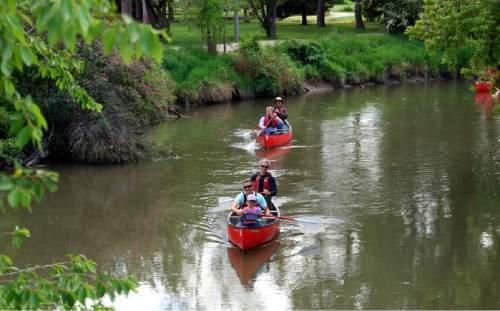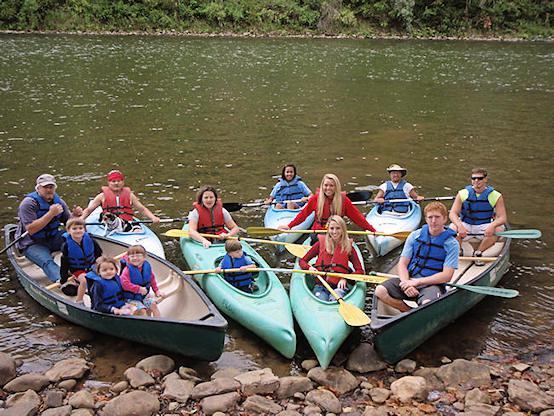The first image is the image on the left, the second image is the image on the right. Given the left and right images, does the statement "The left image contains at least one canoe with multiple people in it heading forward on the water." hold true? Answer yes or no. Yes. The first image is the image on the left, the second image is the image on the right. Considering the images on both sides, is "in at least one image there are two people sitting on a boat." valid? Answer yes or no. No. 